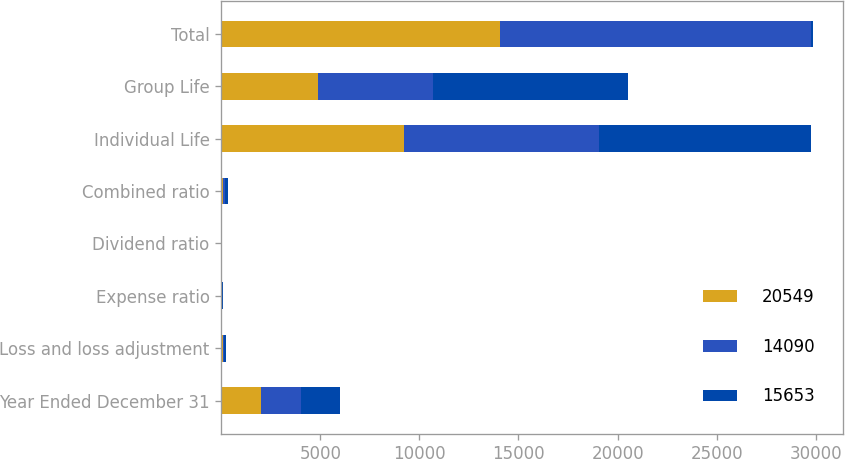Convert chart. <chart><loc_0><loc_0><loc_500><loc_500><stacked_bar_chart><ecel><fcel>Year Ended December 31<fcel>Loss and loss adjustment<fcel>Expense ratio<fcel>Dividend ratio<fcel>Combined ratio<fcel>Individual Life<fcel>Group Life<fcel>Total<nl><fcel>20549<fcel>2007<fcel>77.7<fcel>30<fcel>0.2<fcel>107.9<fcel>9204<fcel>4886<fcel>14090<nl><fcel>14090<fcel>2006<fcel>75.7<fcel>30<fcel>0.3<fcel>106<fcel>9866<fcel>5787<fcel>15653<nl><fcel>15653<fcel>2005<fcel>89.4<fcel>31.2<fcel>0.3<fcel>120.9<fcel>10711<fcel>9838<fcel>120.9<nl></chart> 